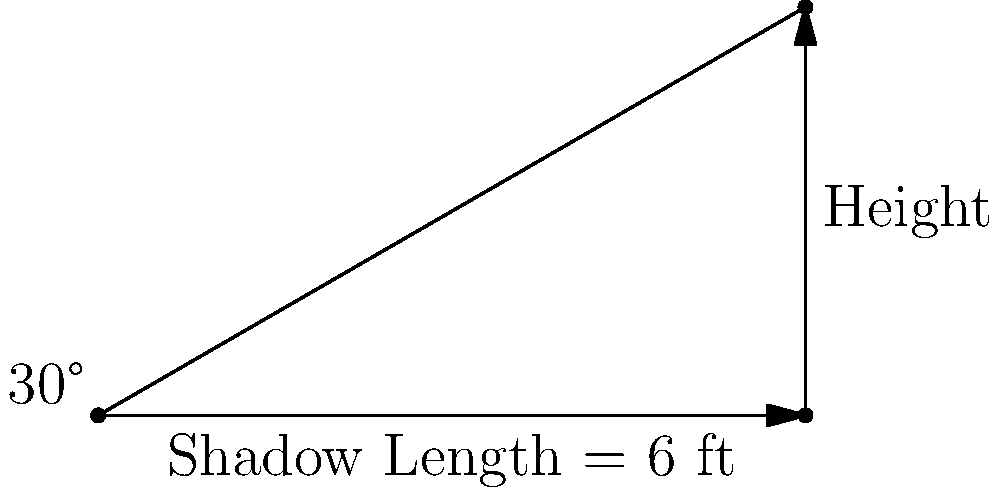During a wrestling event setup, you notice that the shadow of a ring post is 6 feet long when the sun is at a 30-degree angle above the horizon. Using this information, calculate the height of the wrestling ring post to the nearest tenth of a foot. Let's approach this step-by-step using trigonometry:

1) In a right triangle, the tangent of an angle is the ratio of the opposite side to the adjacent side.

2) In this case:
   - The angle is 30° (sun's angle above the horizon)
   - The adjacent side is 6 ft (length of the shadow)
   - The opposite side is the height we're trying to find

3) We can express this relationship as:

   $\tan(30°) = \frac{\text{height}}{\text{shadow length}}$

4) Rearranging the equation:

   $\text{height} = \text{shadow length} \times \tan(30°)$

5) We know the shadow length is 6 ft, so:

   $\text{height} = 6 \times \tan(30°)$

6) $\tan(30°)$ is approximately 0.5774

7) Therefore:

   $\text{height} = 6 \times 0.5774 = 3.4644$ ft

8) Rounding to the nearest tenth:

   $\text{height} \approx 3.5$ ft
Answer: 3.5 ft 